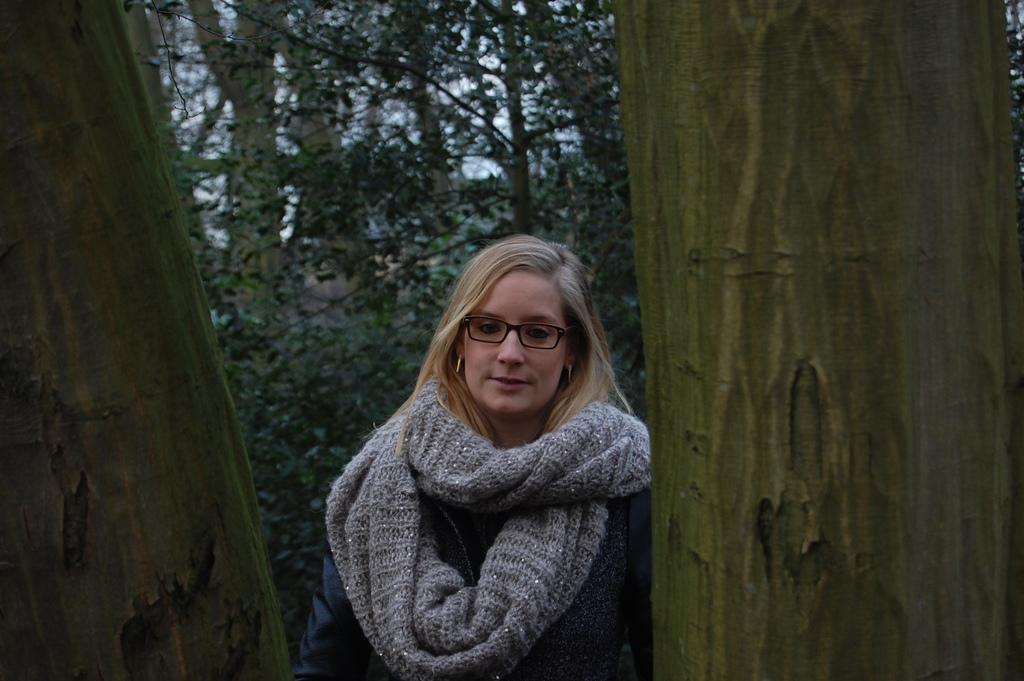Who is visible in the image? There is a woman visible in the image. How is the woman visible in the image? The woman is visible through the trunks of trees. What is behind the woman in the image? There are trees behind the woman. What type of soda can be seen in the woman's hand in the image? There is no soda visible in the woman's hand or anywhere in the image. 